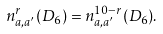<formula> <loc_0><loc_0><loc_500><loc_500>n ^ { r } _ { a , a ^ { \prime } } ( D _ { 6 } ) = n ^ { 1 0 - r } _ { a , a ^ { \prime } } ( D _ { 6 } ) .</formula> 